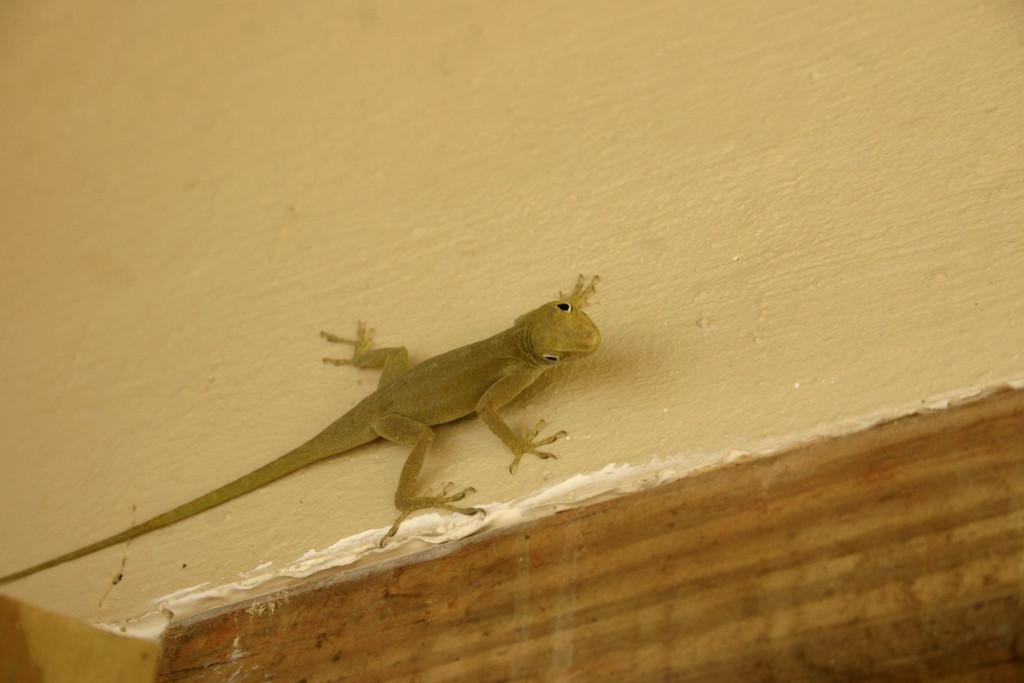Please provide a concise description of this image. In this image I can see a lizard which is in brown color on the cream color surface. 